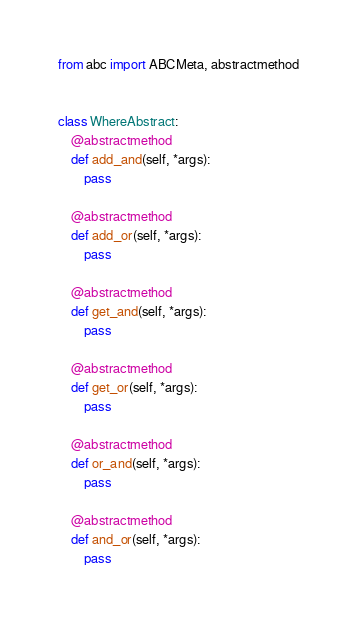<code> <loc_0><loc_0><loc_500><loc_500><_Python_>from abc import ABCMeta, abstractmethod


class WhereAbstract:
    @abstractmethod
    def add_and(self, *args):
        pass

    @abstractmethod
    def add_or(self, *args):
        pass

    @abstractmethod
    def get_and(self, *args):
        pass

    @abstractmethod
    def get_or(self, *args):
        pass

    @abstractmethod
    def or_and(self, *args):
        pass

    @abstractmethod
    def and_or(self, *args):
        pass
</code> 